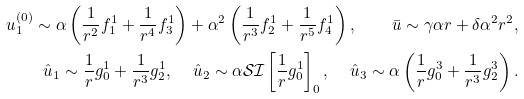<formula> <loc_0><loc_0><loc_500><loc_500>u ^ { ( 0 ) } _ { 1 } \sim \alpha \left ( \frac { 1 } { r ^ { 2 } } f _ { 1 } ^ { 1 } + \frac { 1 } { r ^ { 4 } } f _ { 3 } ^ { 1 } \right ) + \alpha ^ { 2 } \left ( \frac { 1 } { r ^ { 3 } } f _ { 2 } ^ { 1 } + \frac { 1 } { r ^ { 5 } } f _ { 4 } ^ { 1 } \right ) , \, \quad \bar { u } \sim \gamma \alpha r + \delta \alpha ^ { 2 } r ^ { 2 } , \\ \hat { u } _ { 1 } \sim \frac { 1 } { r } g _ { 0 } ^ { 1 } + \frac { 1 } { r ^ { 3 } } g _ { 2 } ^ { 1 } , \, \quad \hat { u } _ { 2 } \sim \alpha \mathcal { S I } \left [ \frac { 1 } { r } g _ { 0 } ^ { 1 } \right ] _ { 0 } , \, \quad \hat { u } _ { 3 } \sim \alpha \left ( \frac { 1 } { r } g _ { 0 } ^ { 3 } + \frac { 1 } { r ^ { 3 } } g _ { 2 } ^ { 3 } \right ) .</formula> 